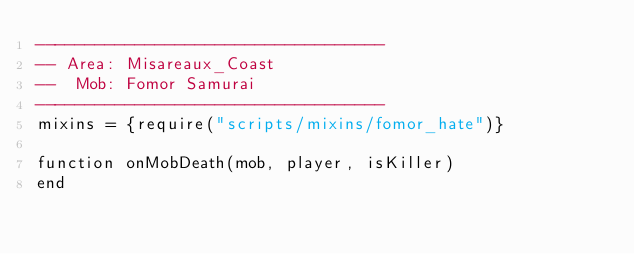Convert code to text. <code><loc_0><loc_0><loc_500><loc_500><_Lua_>-----------------------------------
-- Area: Misareaux_Coast
--  Mob: Fomor Samurai
-----------------------------------
mixins = {require("scripts/mixins/fomor_hate")}

function onMobDeath(mob, player, isKiller)
end
</code> 